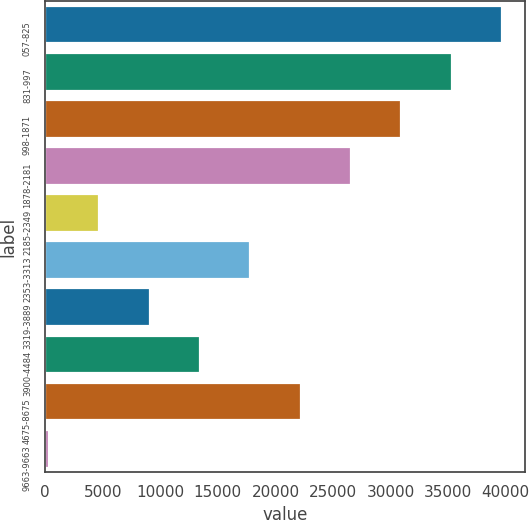<chart> <loc_0><loc_0><loc_500><loc_500><bar_chart><fcel>057-825<fcel>831-997<fcel>998-1871<fcel>1878-2181<fcel>2185-2349<fcel>2353-3313<fcel>3319-3889<fcel>3900-4484<fcel>4675-8675<fcel>9663-9663<nl><fcel>39676<fcel>35304<fcel>30932<fcel>26560<fcel>4700<fcel>17816<fcel>9072<fcel>13444<fcel>22188<fcel>328<nl></chart> 